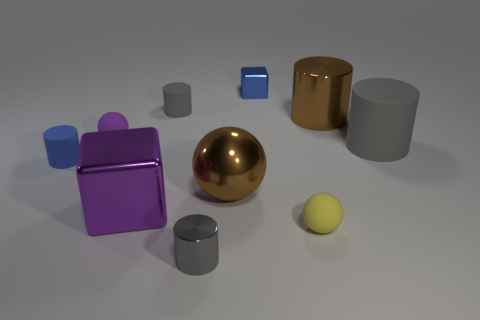Subtract 0 gray cubes. How many objects are left? 10 Subtract all balls. How many objects are left? 7 Subtract 1 cubes. How many cubes are left? 1 Subtract all green balls. Subtract all gray blocks. How many balls are left? 3 Subtract all blue spheres. How many cyan blocks are left? 0 Subtract all purple spheres. Subtract all small shiny cylinders. How many objects are left? 8 Add 3 tiny blue metal objects. How many tiny blue metal objects are left? 4 Add 3 large balls. How many large balls exist? 4 Subtract all brown cylinders. How many cylinders are left? 4 Subtract all purple balls. How many balls are left? 2 